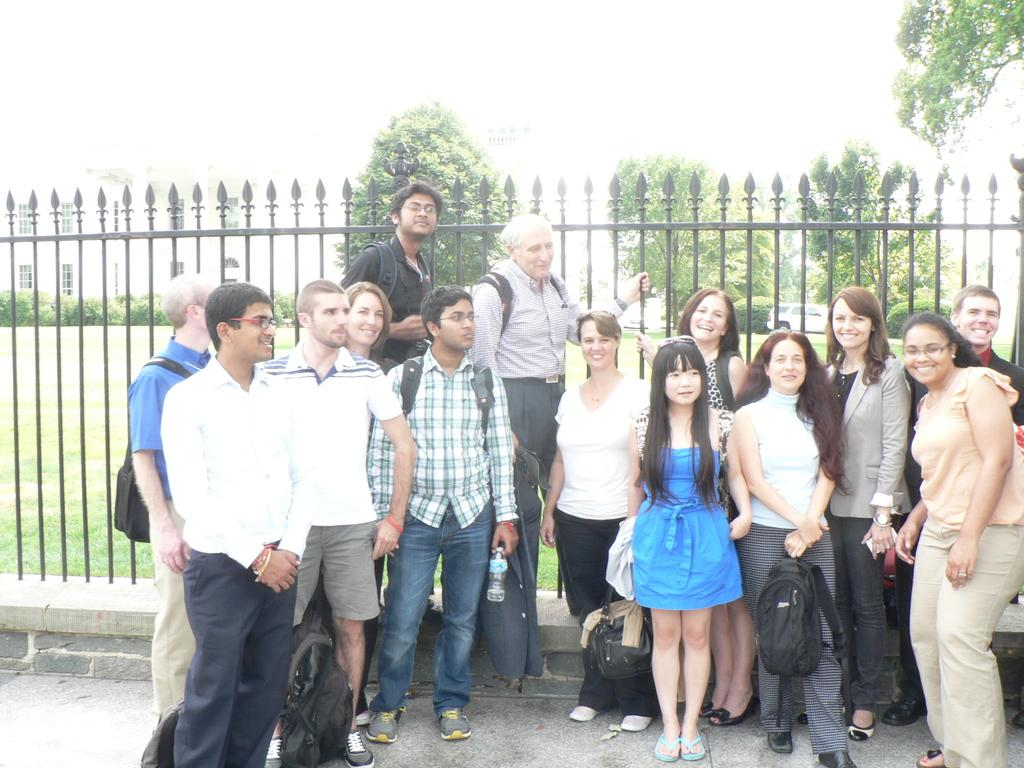How many people are in the group visible in the image? There is a group of people standing in the image, but the exact number cannot be determined from the provided facts. What is the fence made of in the image? The material of the fence is not specified in the provided facts. What type of vegetation is present in the image? There is grass and trees visible in the image. What type of structure can be seen in the image? There is a building in the image. What color is the chalk used by the people in the image? There is no mention of chalk or any writing activity in the image, so it cannot be determined if chalk is present or its color. 